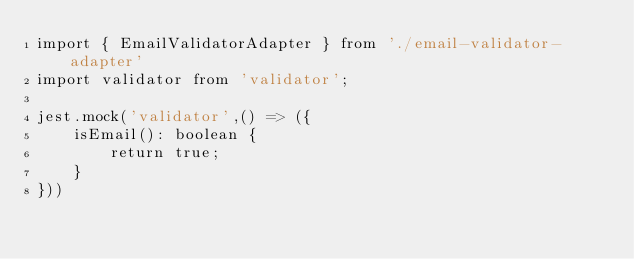Convert code to text. <code><loc_0><loc_0><loc_500><loc_500><_TypeScript_>import { EmailValidatorAdapter } from './email-validator-adapter'
import validator from 'validator';

jest.mock('validator',() => ({
    isEmail(): boolean {
        return true;
    }
}))
</code> 